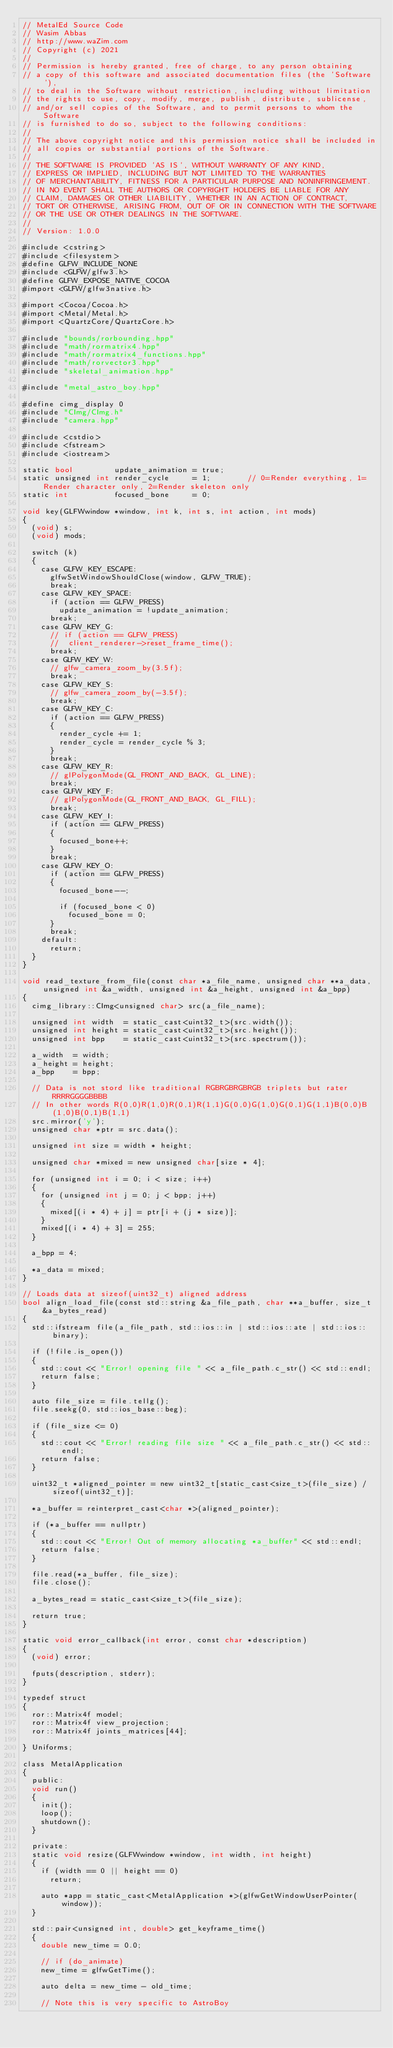<code> <loc_0><loc_0><loc_500><loc_500><_ObjectiveC_>// MetalEd Source Code
// Wasim Abbas
// http://www.waZim.com
// Copyright (c) 2021
//
// Permission is hereby granted, free of charge, to any person obtaining
// a copy of this software and associated documentation files (the 'Software'),
// to deal in the Software without restriction, including without limitation
// the rights to use, copy, modify, merge, publish, distribute, sublicense,
// and/or sell copies of the Software, and to permit persons to whom the Software
// is furnished to do so, subject to the following conditions:
//
// The above copyright notice and this permission notice shall be included in
// all copies or substantial portions of the Software.
//
// THE SOFTWARE IS PROVIDED 'AS IS', WITHOUT WARRANTY OF ANY KIND,
// EXPRESS OR IMPLIED, INCLUDING BUT NOT LIMITED TO THE WARRANTIES
// OF MERCHANTABILITY, FITNESS FOR A PARTICULAR PURPOSE AND NONINFRINGEMENT.
// IN NO EVENT SHALL THE AUTHORS OR COPYRIGHT HOLDERS BE LIABLE FOR ANY
// CLAIM, DAMAGES OR OTHER LIABILITY, WHETHER IN AN ACTION OF CONTRACT,
// TORT OR OTHERWISE, ARISING FROM, OUT OF OR IN CONNECTION WITH THE SOFTWARE
// OR THE USE OR OTHER DEALINGS IN THE SOFTWARE.
//
// Version: 1.0.0

#include <cstring>
#include <filesystem>
#define GLFW_INCLUDE_NONE
#include <GLFW/glfw3.h>
#define GLFW_EXPOSE_NATIVE_COCOA
#import <GLFW/glfw3native.h>

#import <Cocoa/Cocoa.h>
#import <Metal/Metal.h>
#import <QuartzCore/QuartzCore.h>

#include "bounds/rorbounding.hpp"
#include "math/rormatrix4.hpp"
#include "math/rormatrix4_functions.hpp"
#include "math/rorvector3.hpp"
#include "skeletal_animation.hpp"

#include "metal_astro_boy.hpp"

#define cimg_display 0
#include "CImg/CImg.h"
#include "camera.hpp"

#include <cstdio>
#include <fstream>
#include <iostream>

static bool         update_animation = true;
static unsigned int render_cycle     = 1;        // 0=Render everything, 1=Render character only, 2=Render skeleton only
static int          focused_bone     = 0;

void key(GLFWwindow *window, int k, int s, int action, int mods)
{
	(void) s;
	(void) mods;

	switch (k)
	{
		case GLFW_KEY_ESCAPE:
			glfwSetWindowShouldClose(window, GLFW_TRUE);
			break;
		case GLFW_KEY_SPACE:
			if (action == GLFW_PRESS)
				update_animation = !update_animation;
			break;
		case GLFW_KEY_G:
			// if (action == GLFW_PRESS)
			//	client_renderer->reset_frame_time();
			break;
		case GLFW_KEY_W:
			// glfw_camera_zoom_by(3.5f);
			break;
		case GLFW_KEY_S:
			// glfw_camera_zoom_by(-3.5f);
			break;
		case GLFW_KEY_C:
			if (action == GLFW_PRESS)
			{
				render_cycle += 1;
				render_cycle = render_cycle % 3;
			}
			break;
		case GLFW_KEY_R:
			// glPolygonMode(GL_FRONT_AND_BACK, GL_LINE);
			break;
		case GLFW_KEY_F:
			// glPolygonMode(GL_FRONT_AND_BACK, GL_FILL);
			break;
		case GLFW_KEY_I:
			if (action == GLFW_PRESS)
			{
				focused_bone++;
			}
			break;
		case GLFW_KEY_O:
			if (action == GLFW_PRESS)
			{
				focused_bone--;

				if (focused_bone < 0)
					focused_bone = 0;
			}
			break;
		default:
			return;
	}
}

void read_texture_from_file(const char *a_file_name, unsigned char **a_data, unsigned int &a_width, unsigned int &a_height, unsigned int &a_bpp)
{
	cimg_library::CImg<unsigned char> src(a_file_name);

	unsigned int width  = static_cast<uint32_t>(src.width());
	unsigned int height = static_cast<uint32_t>(src.height());
	unsigned int bpp    = static_cast<uint32_t>(src.spectrum());

	a_width  = width;
	a_height = height;
	a_bpp    = bpp;

	// Data is not stord like traditional RGBRGBRGBRGB triplets but rater RRRRGGGGBBBB
	// In other words R(0,0)R(1,0)R(0,1)R(1,1)G(0,0)G(1,0)G(0,1)G(1,1)B(0,0)B(1,0)B(0,1)B(1,1)
	src.mirror('y');
	unsigned char *ptr = src.data();

	unsigned int size = width * height;

	unsigned char *mixed = new unsigned char[size * 4];

	for (unsigned int i = 0; i < size; i++)
	{
		for (unsigned int j = 0; j < bpp; j++)
		{
			mixed[(i * 4) + j] = ptr[i + (j * size)];
		}
		mixed[(i * 4) + 3] = 255;
	}

	a_bpp = 4;

	*a_data = mixed;
}

// Loads data at sizeof(uint32_t) aligned address
bool align_load_file(const std::string &a_file_path, char **a_buffer, size_t &a_bytes_read)
{
	std::ifstream file(a_file_path, std::ios::in | std::ios::ate | std::ios::binary);

	if (!file.is_open())
	{
		std::cout << "Error! opening file " << a_file_path.c_str() << std::endl;
		return false;
	}

	auto file_size = file.tellg();
	file.seekg(0, std::ios_base::beg);

	if (file_size <= 0)
	{
		std::cout << "Error! reading file size " << a_file_path.c_str() << std::endl;
		return false;
	}

	uint32_t *aligned_pointer = new uint32_t[static_cast<size_t>(file_size) / sizeof(uint32_t)];

	*a_buffer = reinterpret_cast<char *>(aligned_pointer);

	if (*a_buffer == nullptr)
	{
		std::cout << "Error! Out of memory allocating *a_buffer" << std::endl;
		return false;
	}

	file.read(*a_buffer, file_size);
	file.close();

	a_bytes_read = static_cast<size_t>(file_size);

	return true;
}

static void error_callback(int error, const char *description)
{
	(void) error;

	fputs(description, stderr);
}

typedef struct
{
	ror::Matrix4f model;
	ror::Matrix4f view_projection;
	ror::Matrix4f joints_matrices[44];

} Uniforms;

class MetalApplication
{
  public:
	void run()
	{
		init();
		loop();
		shutdown();
	}

  private:
	static void resize(GLFWwindow *window, int width, int height)
	{
		if (width == 0 || height == 0)
			return;

		auto *app = static_cast<MetalApplication *>(glfwGetWindowUserPointer(window));
	}

	std::pair<unsigned int, double> get_keyframe_time()
	{
		double new_time = 0.0;

		// if (do_animate)
		new_time = glfwGetTime();

		auto delta = new_time - old_time;

		// Note this is very specific to AstroBoy</code> 